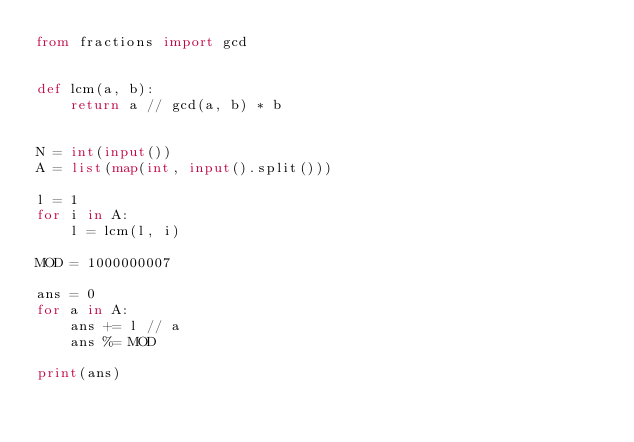Convert code to text. <code><loc_0><loc_0><loc_500><loc_500><_Python_>from fractions import gcd


def lcm(a, b):
    return a // gcd(a, b) * b


N = int(input())
A = list(map(int, input().split()))

l = 1
for i in A:
    l = lcm(l, i)

MOD = 1000000007

ans = 0
for a in A:
    ans += l // a
    ans %= MOD

print(ans)
</code> 